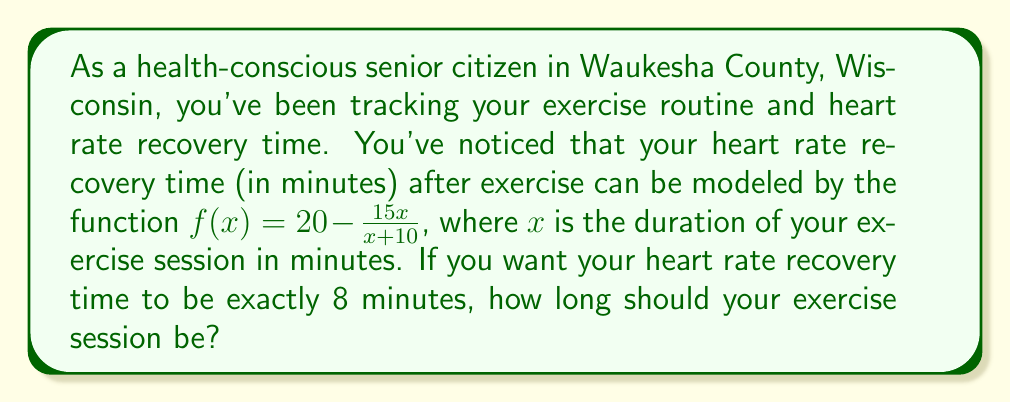Help me with this question. Let's approach this step-by-step:

1) We want to find $x$ when $f(x) = 8$. So, we can set up the equation:

   $8 = 20 - \frac{15x}{x+10}$

2) Subtract 20 from both sides:

   $-12 = - \frac{15x}{x+10}$

3) Multiply both sides by $(x+10)$:

   $-12(x+10) = -15x$

4) Expand the left side:

   $-12x - 120 = -15x$

5) Add $15x$ to both sides:

   $3x - 120 = 0$

6) Add 120 to both sides:

   $3x = 120$

7) Divide both sides by 3:

   $x = 40$

Therefore, your exercise session should last 40 minutes to achieve a heart rate recovery time of exactly 8 minutes.
Answer: 40 minutes 